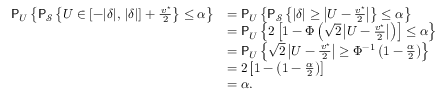<formula> <loc_0><loc_0><loc_500><loc_500>\begin{array} { r l } { P _ { U } \left \{ P _ { \mathcal { S } } \left \{ U \in [ - | \delta | , \, | \delta | ] + \frac { \, v ^ { ^ { * } } } { 2 } \right \} \leq \alpha \right \} } & { = P _ { U } \left \{ P _ { \mathcal { S } } \left \{ | \delta | \geq \left | U - \frac { v ^ { ^ { * } } } { 2 } \right | \right \} \leq \alpha \right \} } \\ & { = P _ { U } \left \{ 2 \left [ 1 - \Phi \left ( \sqrt { 2 } \left | U - \frac { v ^ { ^ { * } } } { 2 } \right | \right ) \right ] \leq \alpha \right \} } \\ & { = P _ { U } \left \{ \sqrt { 2 } \left | U - \frac { \, v ^ { ^ { * } } } { 2 } \right | \geq \Phi ^ { - 1 } \left ( 1 - \frac { \alpha } { 2 } \right ) \right \} } \\ & { = 2 \left [ 1 - \left ( 1 - \frac { \alpha } { 2 } \right ) \right ] } \\ & { = \alpha . } \end{array}</formula> 